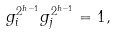Convert formula to latex. <formula><loc_0><loc_0><loc_500><loc_500>g _ { i } ^ { 2 ^ { h - 1 } } g _ { j } ^ { 2 ^ { h - 1 } } = 1 ,</formula> 